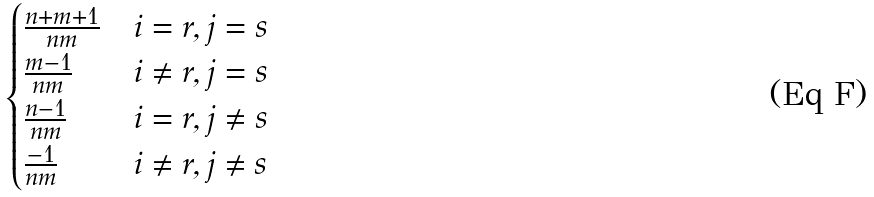<formula> <loc_0><loc_0><loc_500><loc_500>\begin{cases} \frac { n + m + 1 } { n m } & i = r , j = s \\ \frac { m - 1 } { n m } & i \neq r , j = s \\ \frac { n - 1 } { n m } & i = r , j \neq s \\ \frac { - 1 } { n m } & i \neq r , j \neq s \end{cases}</formula> 